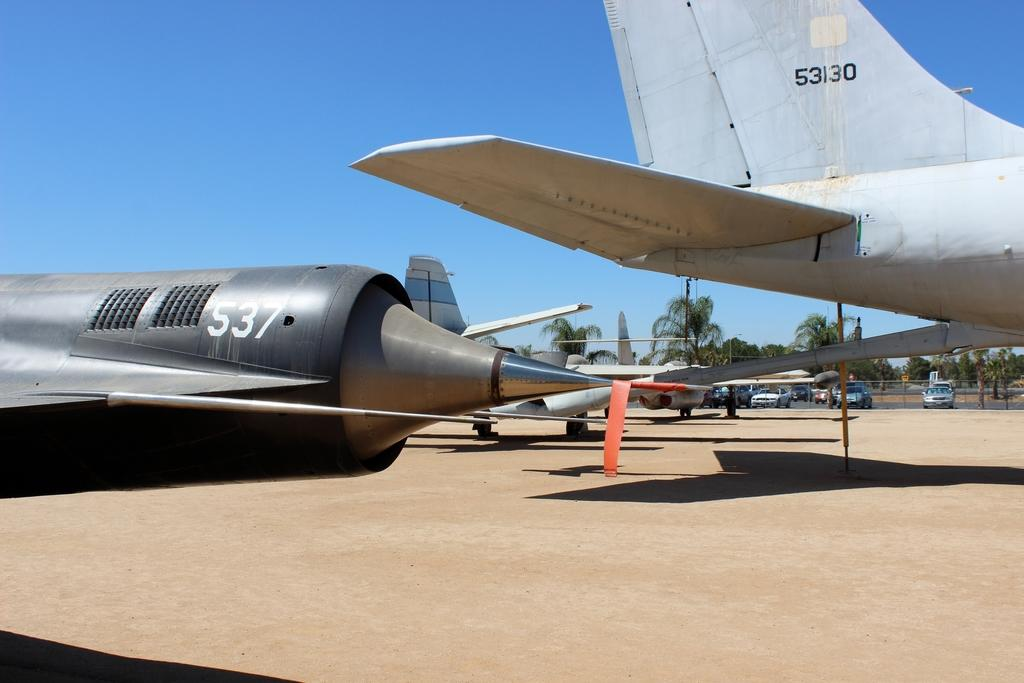<image>
Give a short and clear explanation of the subsequent image. A black pointy airplane has the number 537 on its nose. 